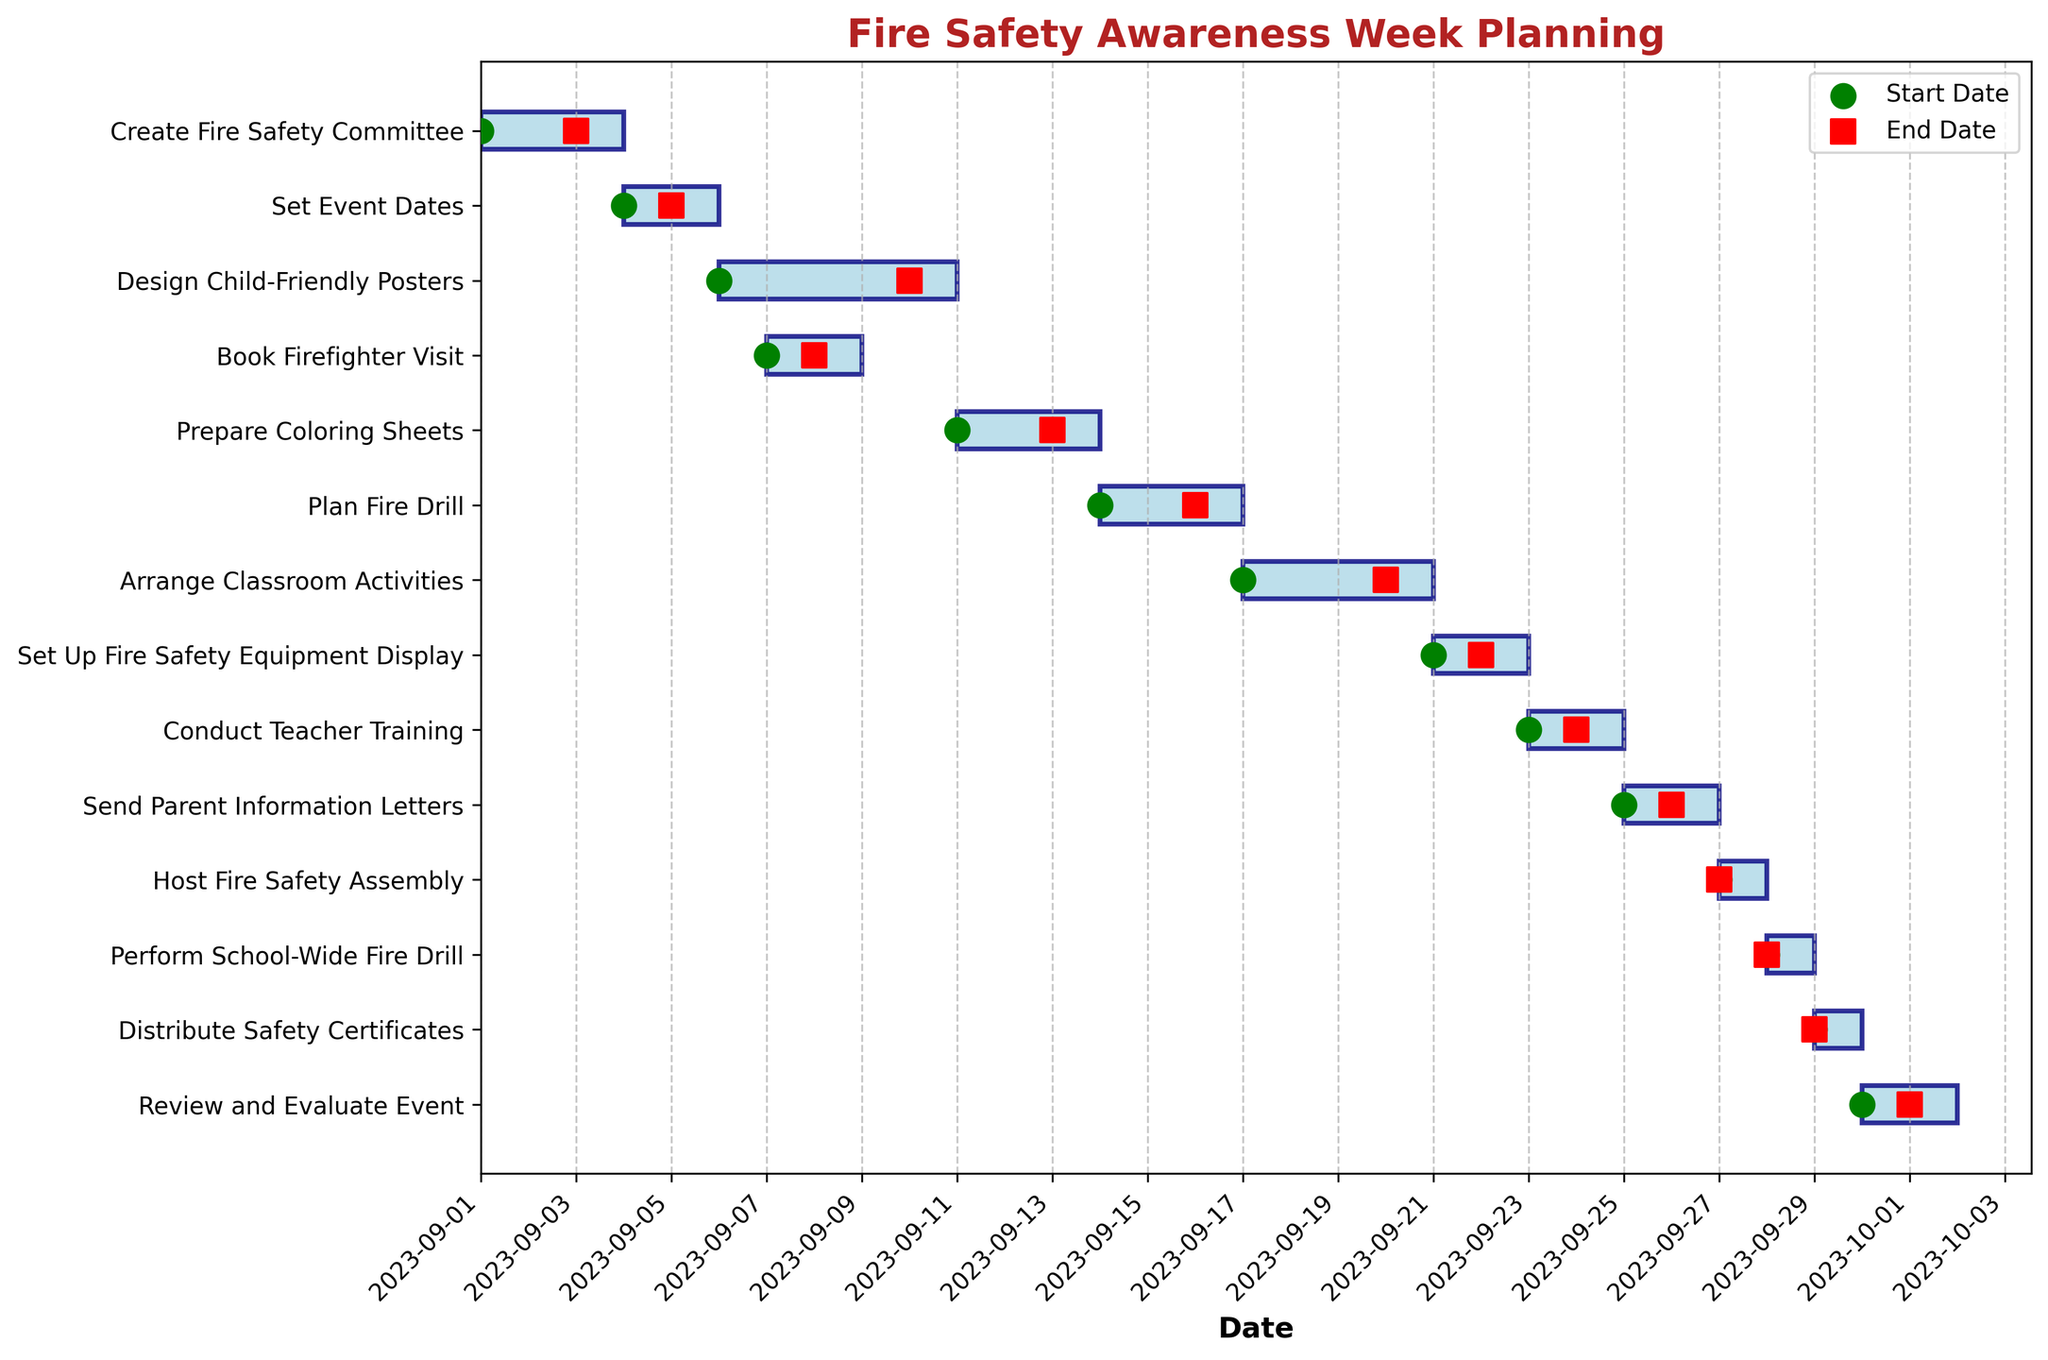What's the title of the chart? The title is located at the top center of the chart and is typically in a larger, bold font. It summarizes the focus of the chart. In this case, it reads "Fire Safety Awareness Week Planning."
Answer: Fire Safety Awareness Week Planning What are the start and end dates for designing the child-friendly posters? Look for the bar labeled "Design Child-Friendly Posters" on the y-axis. Follow the start and end markers at the horizontal ends of this bar. The green circle and red square indicate the start and end dates, respectively. The dates are displayed on the x-axis.
Answer: 2023-09-06 to 2023-09-10 How long does it take to plan the fire drill? Locate the bar labeled "Plan Fire Drill." Note the start date and the end date by following the markers. The planning period is from 2023-09-14 to 2023-09-16, which is 3 days.
Answer: 3 days Which task starts right after booking the firefighter visit? Find the bar labeled "Book Firefighter Visit" and look at its end date. Locate the task with its start date immediately following this. "Prepare Coloring Sheets" starts right after "Book Firefighter Visit" on 2023-09-11.
Answer: Prepare Coloring Sheets How many tasks are scheduled to be completed on a single day? Look for bars that begin and end on the same date, marked by a green circle and red square on the same vertical line. There are multiple tasks like "Host Fire Safety Assembly" on 2023-09-27, "Perform School-Wide Fire Drill" on 2023-09-28, and "Distribute Safety Certificates" on 2023-09-29. In this case, it is three tasks.
Answer: Three What task has the longest duration? Compare the length of all bars horizontally. The longest bar signifies the longest duration. Here, "Design Child-Friendly Posters" is the longest, spanning 5 days from 2023-09-06 to 2023-09-10.
Answer: Design Child-Friendly Posters Which tasks overlap with each other in the first week of September? Check for bars that share the same horizontal span in the first week. "Create Fire Safety Committee" and "Set Event Dates" overlap from 2023-09-01 to 2023-09-03, and "Set Event Dates" spans into 2023-09-04 - 2023-09-05.
Answer: Create Fire Safety Committee and Set Event Dates When do classroom activities start being arranged relative to the teacher training? Find the start dates of "Arrange Classroom Activities" and "Conduct Teacher Training." "Arrange Classroom Activities" starts on 2023-09-17 and ends on 2023-09-20. "Conduct Teacher Training" starts on 2023-09-23. This means the classroom activities are arranged just before the teacher training.
Answer: Before How many days are allocated to review and evaluate the event? Look at the bar labeled "Review and Evaluate Event." Identify the start and end dates, which are 2023-09-30 to 2023-10-01. The total duration is 2 days.
Answer: 2 days Which two tasks are scheduled back-to-back with no gap in between? Find tasks where the end date of one is the start date of another. For instance, "Send Parent Information Letters" ends on 2023-09-26 and "Host Fire Safety Assembly" starts on 2023-09-27 the next day.
Answer: Send Parent Information Letters and Host Fire Safety Assembly 